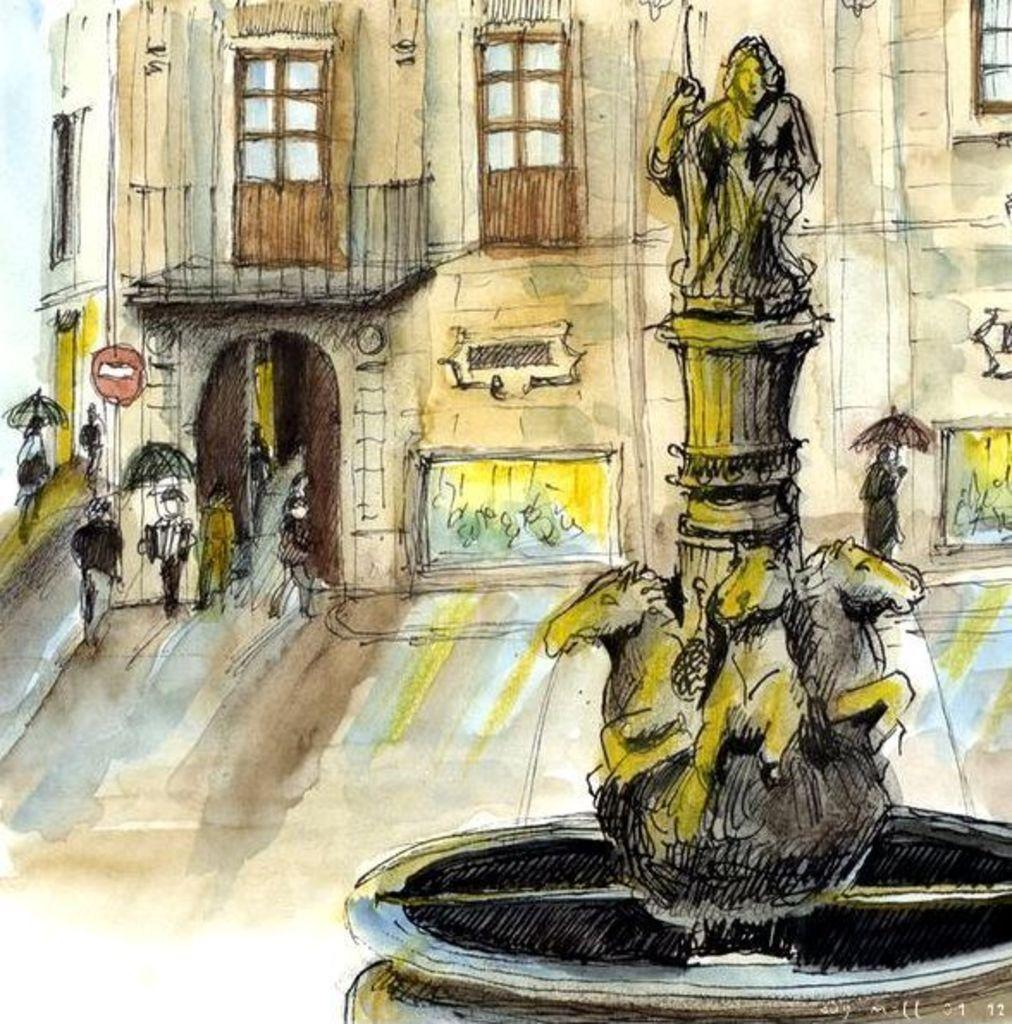What types of subjects are shown in the image? There are people, sculptures, and buildings depicted in the image. Can you describe the people in the image? The facts provided do not give specific details about the people in the image. What can you tell us about the sculptures in the image? The facts provided do not give specific details about the sculptures in the image. What can you tell us about the buildings in the image? The facts provided do not give specific details about the buildings in the image. What type of root is growing near the people in the image? There is no root present in the image; the subjects are people, sculptures, and buildings. 